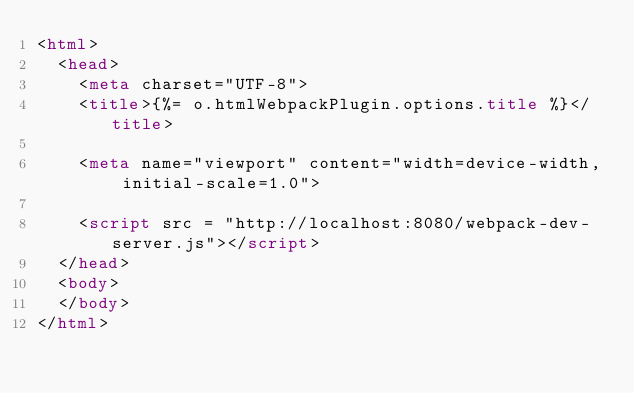Convert code to text. <code><loc_0><loc_0><loc_500><loc_500><_HTML_><html>
  <head>
    <meta charset="UTF-8">
    <title>{%= o.htmlWebpackPlugin.options.title %}</title>

    <meta name="viewport" content="width=device-width, initial-scale=1.0">

    <script src = "http://localhost:8080/webpack-dev-server.js"></script>
  </head>
  <body>
  </body>
</html>
</code> 